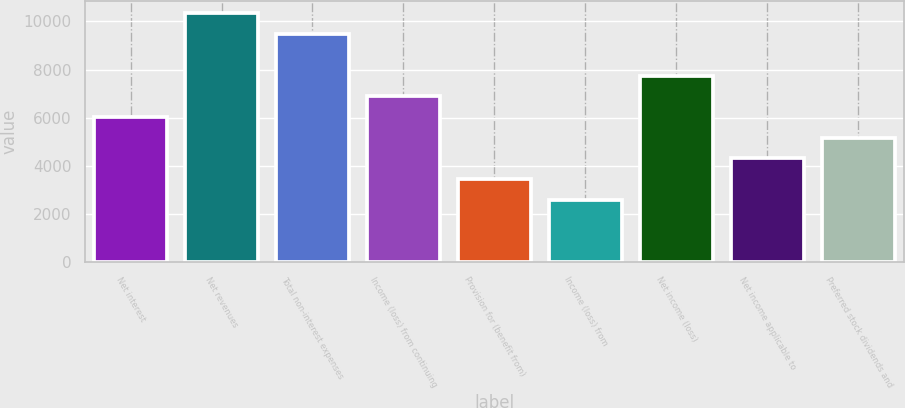<chart> <loc_0><loc_0><loc_500><loc_500><bar_chart><fcel>Net interest<fcel>Net revenues<fcel>Total non-interest expenses<fcel>Income (loss) from continuing<fcel>Provision for (benefit from)<fcel>Income (loss) from<fcel>Net income (loss)<fcel>Net income applicable to<fcel>Preferred stock dividends and<nl><fcel>6025.63<fcel>10329.6<fcel>9468.79<fcel>6886.42<fcel>3443.26<fcel>2582.47<fcel>7747.21<fcel>4304.05<fcel>5164.84<nl></chart> 